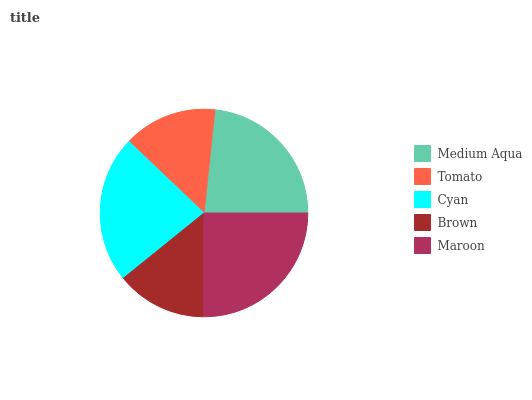Is Brown the minimum?
Answer yes or no. Yes. Is Maroon the maximum?
Answer yes or no. Yes. Is Tomato the minimum?
Answer yes or no. No. Is Tomato the maximum?
Answer yes or no. No. Is Medium Aqua greater than Tomato?
Answer yes or no. Yes. Is Tomato less than Medium Aqua?
Answer yes or no. Yes. Is Tomato greater than Medium Aqua?
Answer yes or no. No. Is Medium Aqua less than Tomato?
Answer yes or no. No. Is Cyan the high median?
Answer yes or no. Yes. Is Cyan the low median?
Answer yes or no. Yes. Is Medium Aqua the high median?
Answer yes or no. No. Is Brown the low median?
Answer yes or no. No. 